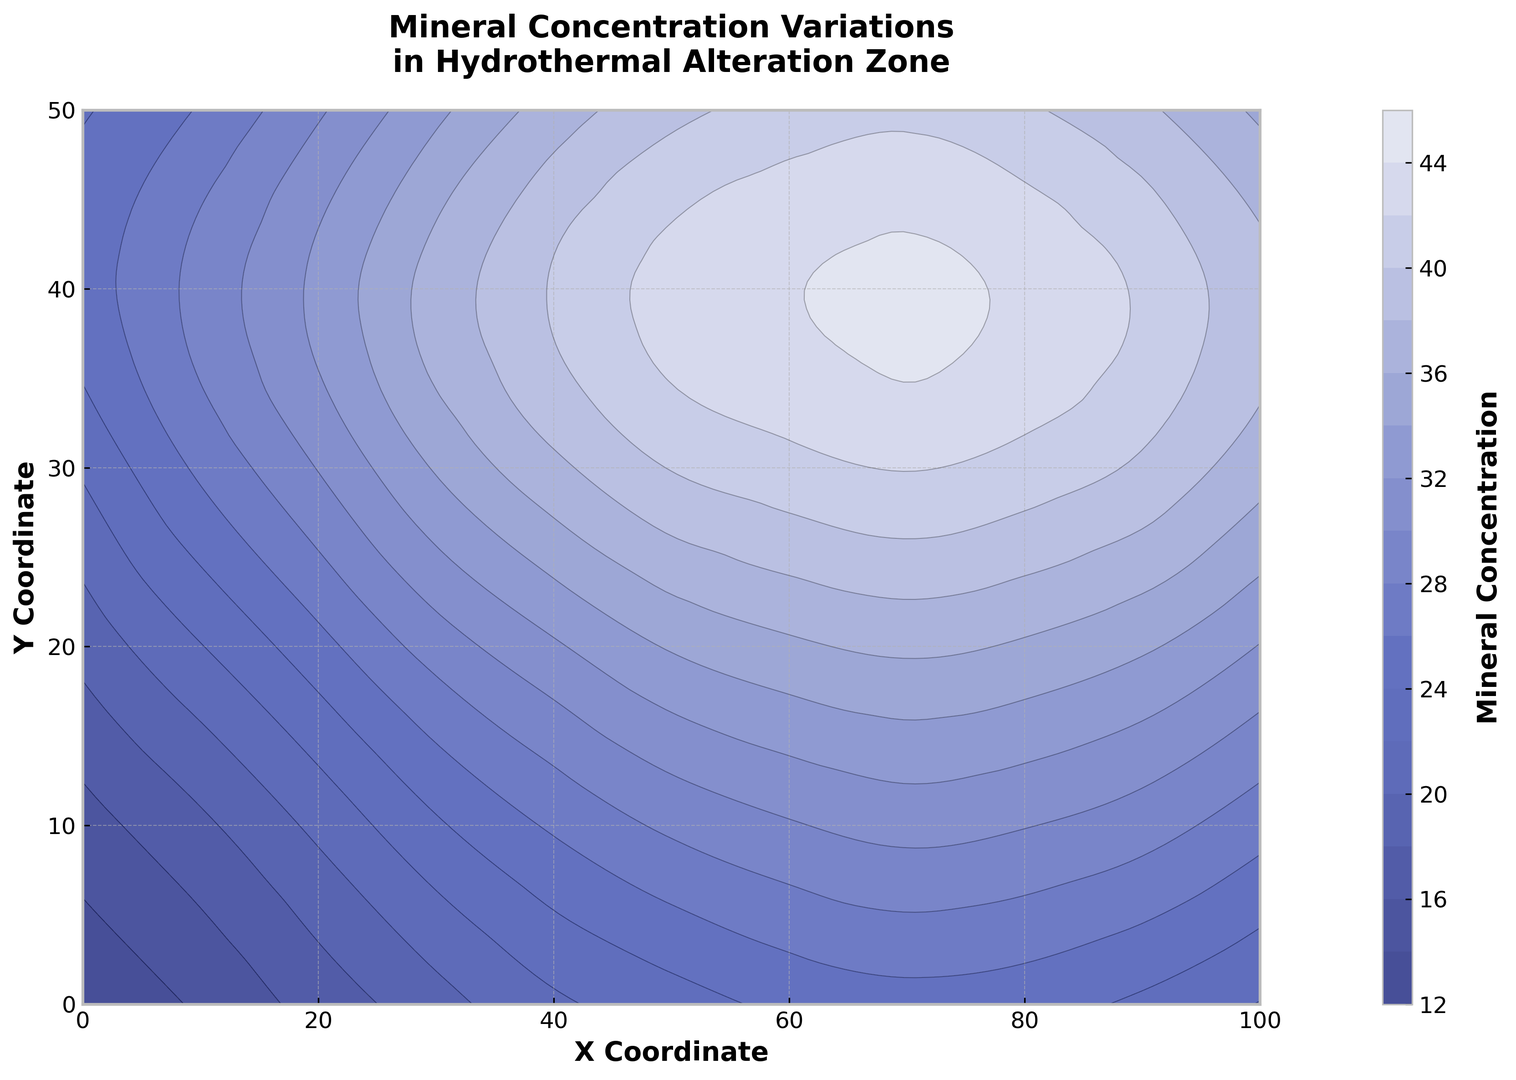Which region has the highest mineral concentration? By looking at the contour plot, identify the area with the darkest shading, which corresponds to the highest mineral concentration, typically in the upper-right part of the plot.
Answer: The upper-right region Where is the lowest mineral concentration located? Locate the area with the lightest shading on the contour plot, typically found in the lower-left region of the plot.
Answer: The lower-left region Compare the mineral concentration at (50, 30) and (50, 40). Which one is higher? Refer to the contour plot and find the values corresponding to the coordinates (50, 30) and (50, 40). Notice that the concentration at (50, 40) is slightly higher based on the color shading.
Answer: (50, 40) What is the average mineral concentration along the y-axis at x = 50? Locate the points along x = 50 on the contour plot, sum their values (23.8, 26.2, 29.7, 33.5, 36.9, 39.4), and calculate the average. Average = (23.8 + 26.2 + 29.7 + 33.5 + 36.9 + 39.4)/6.
Answer: 31.58 Is the mineral concentration gradient steeper along the x-axis or y-axis? Compare the change in concentration between neighboring contours along x and y axes. The contour plot indicates a more significant gradient along the x-axis than the y-axis, as the changes are more rapid horizontally.
Answer: x-axis Where are the steepest gradients in mineral concentration located? Look for areas on the contour plot where contours are tightly packed, which represent steep gradients. These are typically found in the middle-right part of the plot.
Answer: Middle-right region What is the contour line interval for mineral concentration values, approximately? Observe the contour lines on the plot and estimate the difference in mineral concentration between adjacent lines, approximately 3 to 4 units.
Answer: Approximately 3 to 4 units How does the mineral concentration change from (10, 10) to (30, 30)? Observe the contour lines between the two points on the plot. The concentration increases from 17.6 at (10, 10) to 34.2 at (30, 30).
Answer: It increases Compare the mineral concentration at (90, 10) with that at (20, 40). Which one is higher? Refer to the contour values at the coordinates. The concentration at (90, 10) is 28.9, while at (20, 40) is 32.5.
Answer: (20, 40) Is there a noticeable trend in mineral concentration as you move from left to right (along the x-axis)? Identify if there's a general pattern in the contour plot. The plot shows that the mineral concentration generally increases from left to right.
Answer: Yes, it increases 